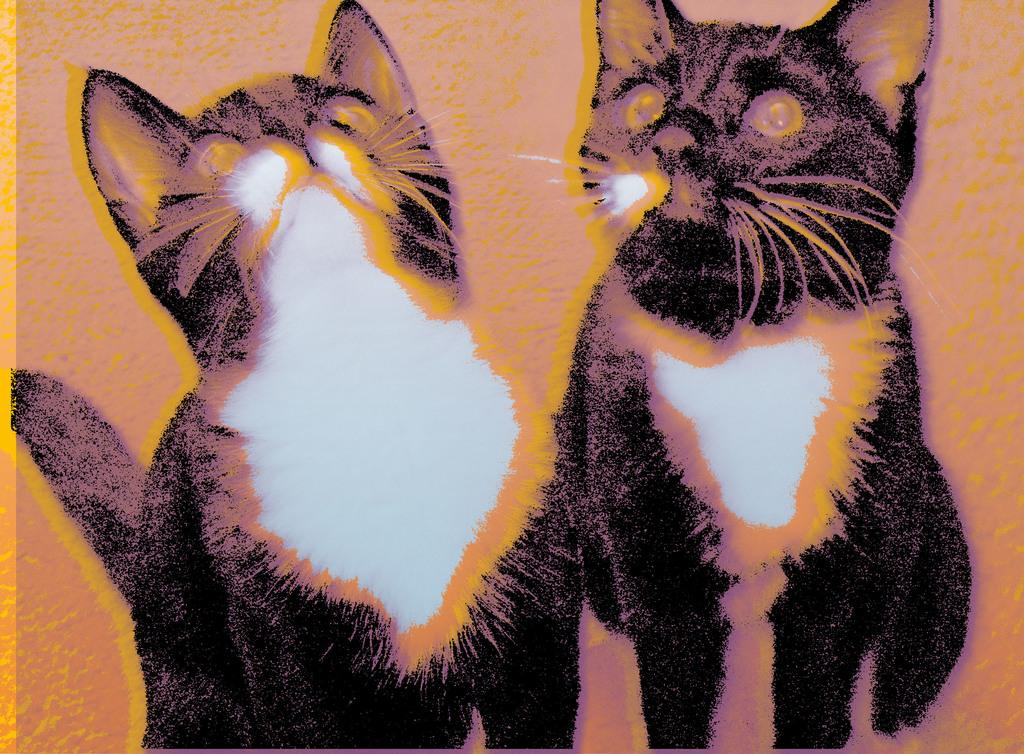What type of picture is shown in the image? There is an animated picture in the image. What animals are depicted in the animated picture? The picture depicts two cats. What song is being sung by the cats in the image? There is no indication in the image that the cats are singing a song. 